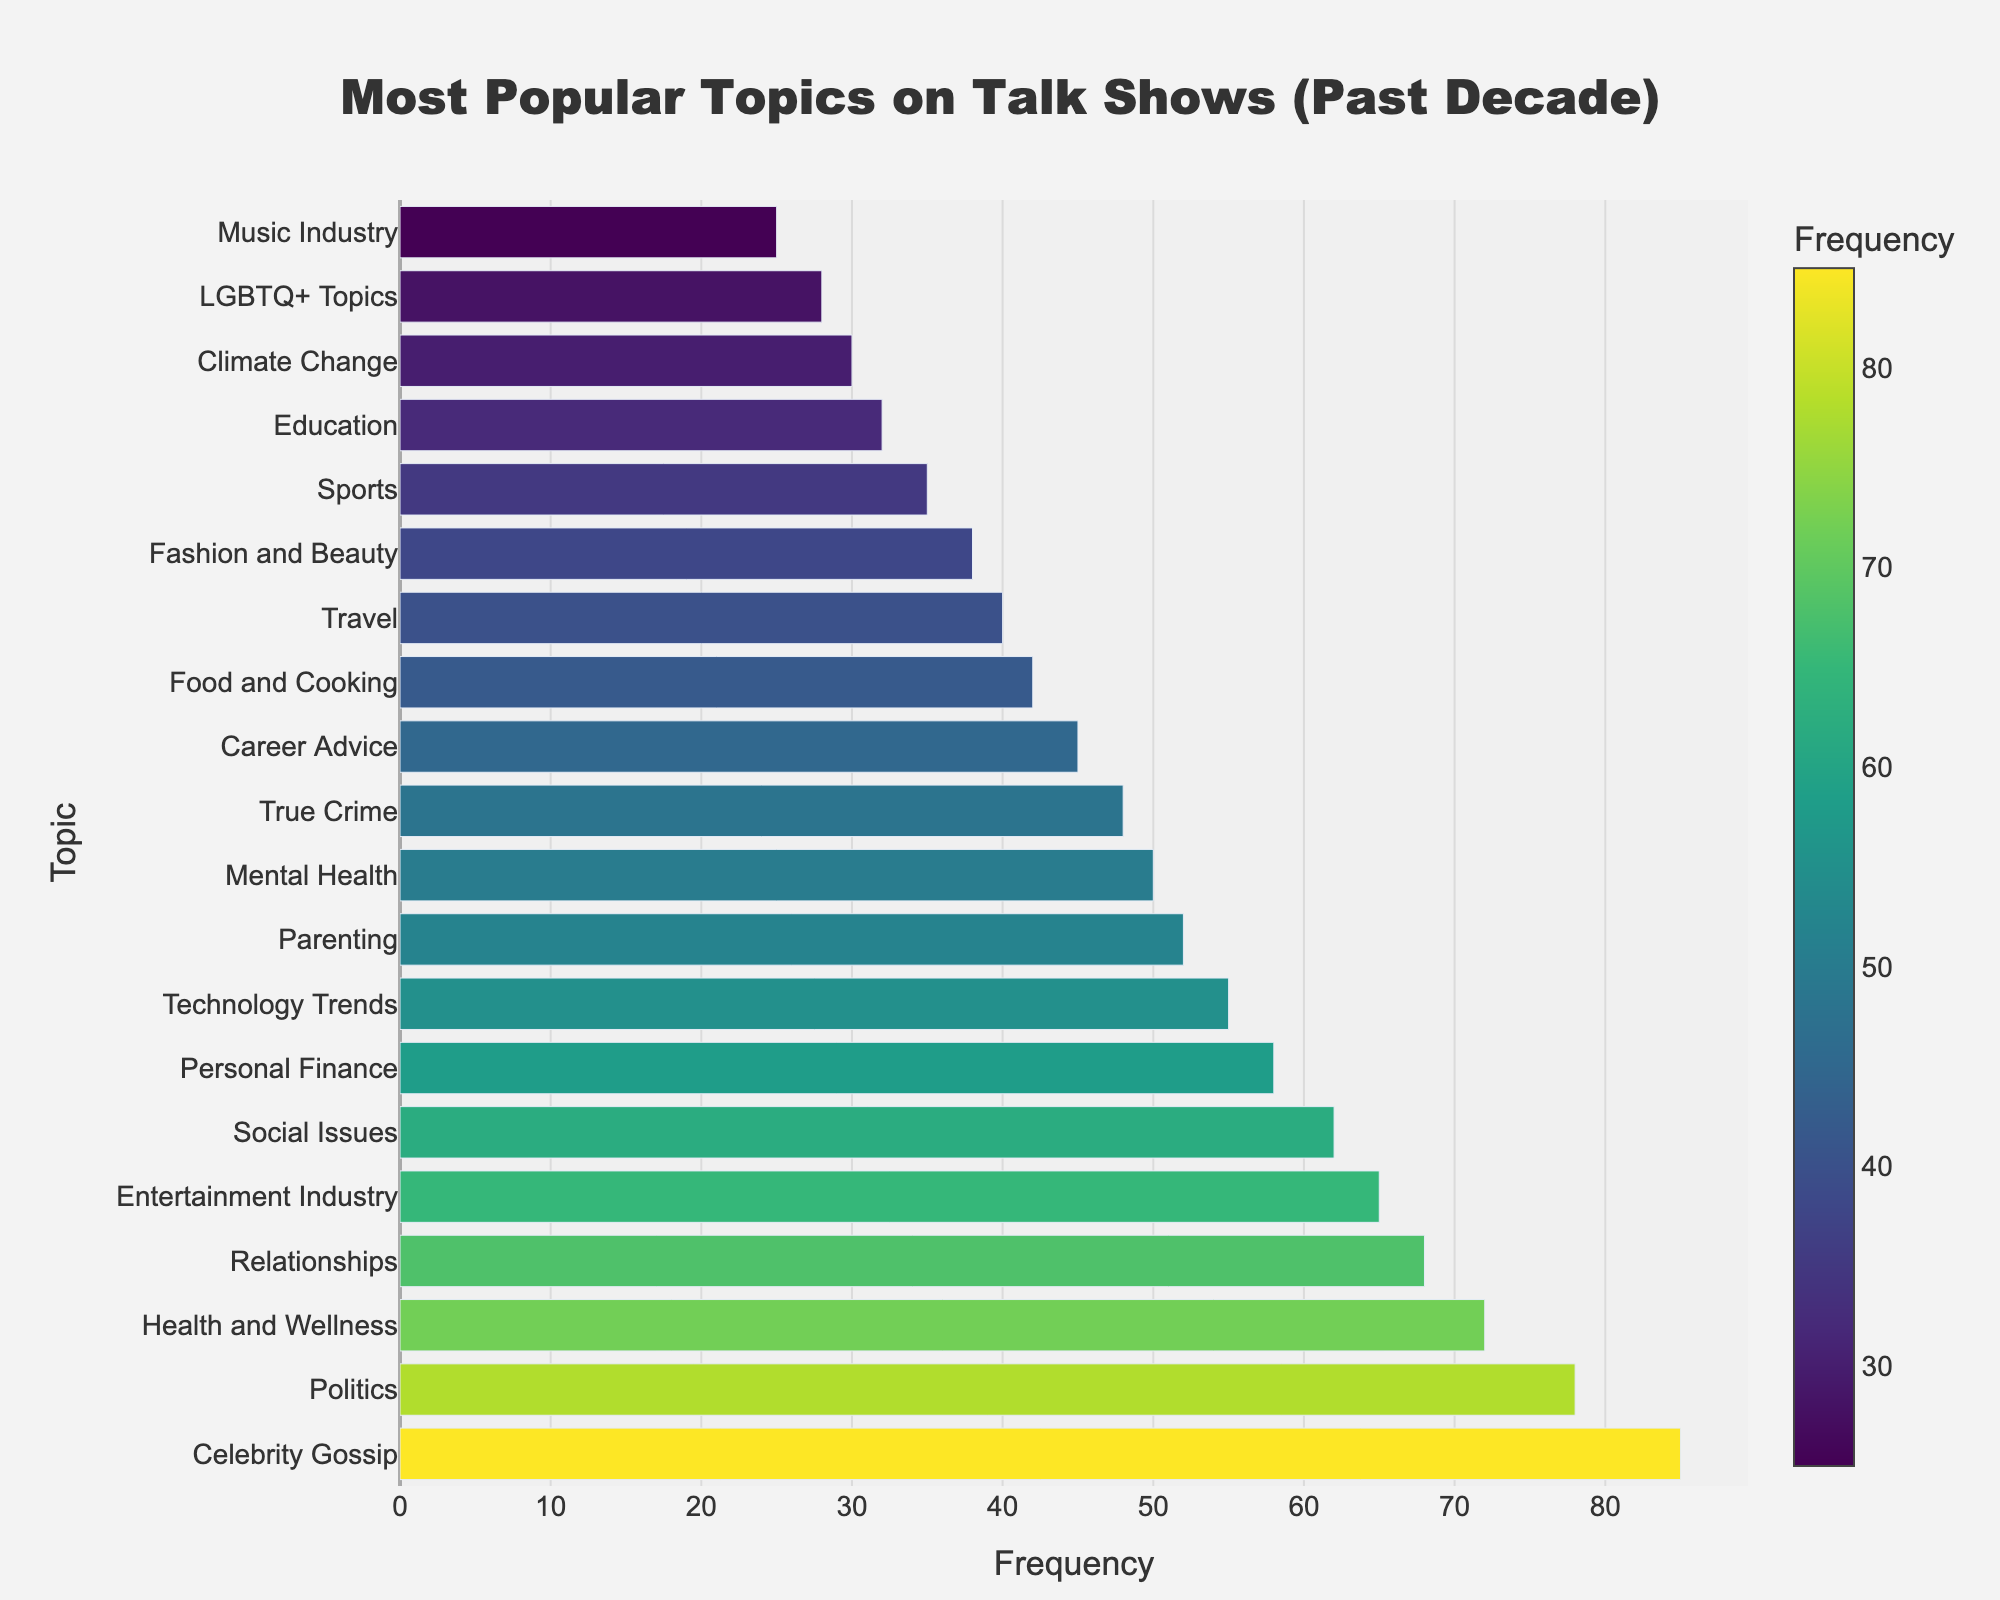What is the most frequently discussed topic on talk shows over the past decade? The most frequently discussed topic is the one with the highest bar in the chart. By looking at the chart, "Celebrity Gossip" has the highest frequency.
Answer: Celebrity Gossip How much more frequently is "Politics" discussed compared to "True Crime"? We look at the frequency of "Politics" and "True Crime" on the chart. "Politics" is 78 and "True Crime" is 48. The difference is 78 - 48.
Answer: 30 Which topic is discussed more frequently: "Mental Health" or "Personal Finance"? By comparing the lengths of the bars, we see that "Mental Health" has a frequency of 50, whereas "Personal Finance" has 58.
Answer: Personal Finance What is the sum of the frequencies of "Health and Wellness," "Relationships," and "Entertainment Industry"? We find the frequencies from the chart: "Health and Wellness" is 72, "Relationships" is 68, and "Entertainment Industry" is 65. The sum is 72 + 68 + 65.
Answer: 205 Does "Technology Trends" have a higher frequency than "Parenting"? By comparing the bars, "Technology Trends" has a frequency of 55, and "Parenting" has a frequency of 52.
Answer: Yes What is the difference in frequency between the least and most discussed topics? The frequency of the least discussed topic "Music Industry" is 25 and the most discussed topic "Celebrity Gossip" is 85. The difference is 85 - 25.
Answer: 60 On average, how frequently are the top three topics discussed? The top three topics are "Celebrity Gossip" (85), "Politics" (78), and "Health and Wellness" (72). The average is (85 + 78 + 72) / 3.
Answer: 78.33 Among "Food and Cooking," "Travel," and "Fashion and Beauty," which topic has the highest frequency? By comparing the bars, "Food and Cooking" has a frequency of 42, "Travel" has 40, and "Fashion and Beauty" has 38. The highest is "Food and Cooking."
Answer: Food and Cooking What is the median frequency of all the topics? To find the median, we arrange all the frequencies in ascending order and find the middle value. The middle values are 50 and 52. The median is (50 + 52) / 2.
Answer: 51 Is "Climate Change" discussed more frequently than "Education"? Comparing the lengths of the bars, "Climate Change" has a frequency of 30, and "Education" has 32.
Answer: No 